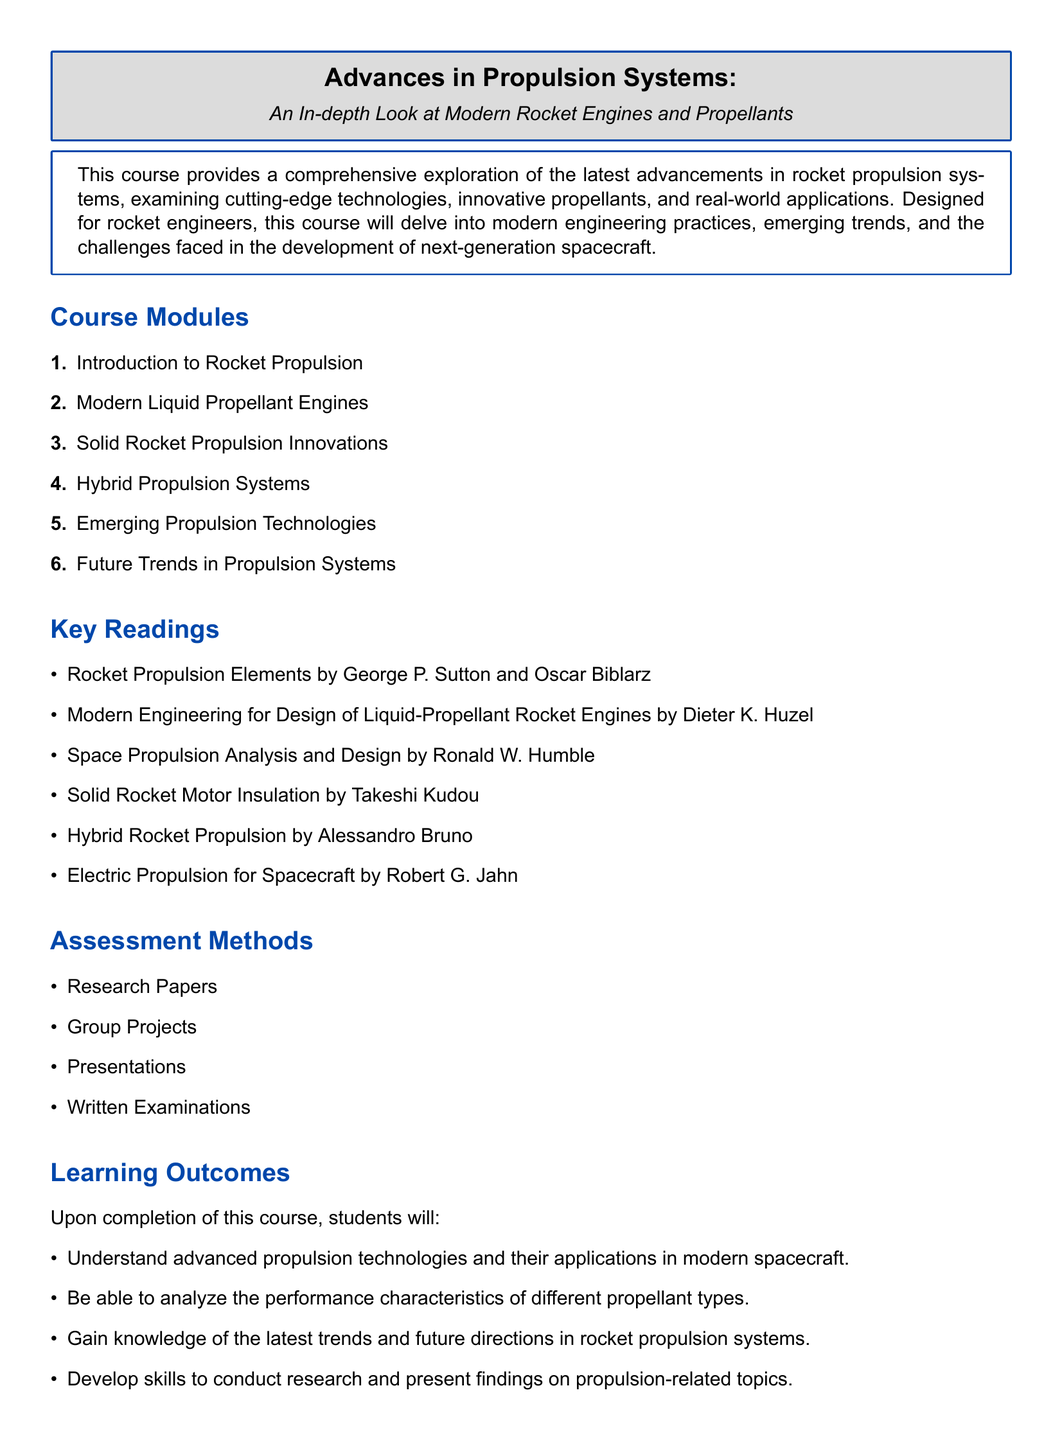What is the title of the course? The title of the course is mentioned first in the document.
Answer: Advances in Propulsion Systems: An In-depth Look at Modern Rocket Engines and Propellants How many course modules are listed? The document lists six course modules under the "Course Modules" section.
Answer: 6 Name one key reading recommended for this course. The "Key Readings" section provides a list of recommended readings.
Answer: Rocket Propulsion Elements What are the assessment methods used in this course? The "Assessment Methods" section lists various methods used to evaluate students.
Answer: Research Papers What learning outcome involves analyzing performance? The specific learning outcome related to analysis is found in the "Learning Outcomes" section.
Answer: Analyze the performance characteristics of different propellant types Which propulsion system technology is focused on emerging trends? The relevant module that addresses emerging trends is specified in the course modules.
Answer: Emerging Propulsion Technologies What is the main purpose of this course? The purpose is stated in the initial paragraph of the course description.
Answer: Comprehensive exploration of the latest advancements in rocket propulsion systems What types of propulsion systems are discussed in the course? The "Course Modules" section outlines the different propulsion systems covered.
Answer: Liquid, Solid, Hybrid 